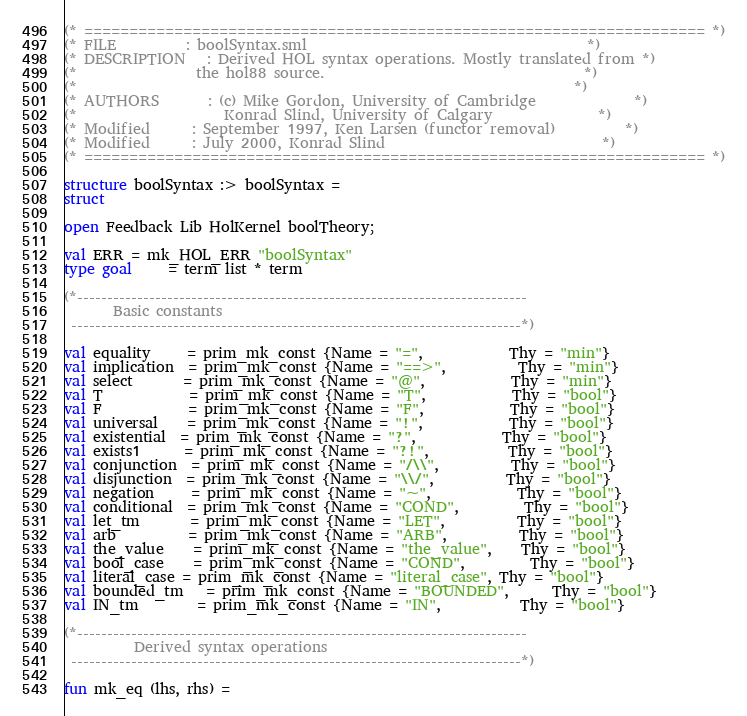Convert code to text. <code><loc_0><loc_0><loc_500><loc_500><_SML_>(* ===================================================================== *)
(* FILE          : boolSyntax.sml                                        *)
(* DESCRIPTION   : Derived HOL syntax operations. Mostly translated from *)
(*                 the hol88 source.                                     *)
(*                                                                       *)
(* AUTHORS       : (c) Mike Gordon, University of Cambridge              *)
(*                     Konrad Slind, University of Calgary               *)
(* Modified      : September 1997, Ken Larsen (functor removal)          *)
(* Modified      : July 2000, Konrad Slind                               *)
(* ===================================================================== *)

structure boolSyntax :> boolSyntax =
struct

open Feedback Lib HolKernel boolTheory;

val ERR = mk_HOL_ERR "boolSyntax"
type goal     = term list * term

(*---------------------------------------------------------------------------
       Basic constants
 ---------------------------------------------------------------------------*)

val equality     = prim_mk_const {Name = "=",            Thy = "min"}
val implication  = prim_mk_const {Name = "==>",          Thy = "min"}
val select       = prim_mk_const {Name = "@",            Thy = "min"}
val T            = prim_mk_const {Name = "T",            Thy = "bool"}
val F            = prim_mk_const {Name = "F",            Thy = "bool"}
val universal    = prim_mk_const {Name = "!",            Thy = "bool"}
val existential  = prim_mk_const {Name = "?",            Thy = "bool"}
val exists1      = prim_mk_const {Name = "?!",           Thy = "bool"}
val conjunction  = prim_mk_const {Name = "/\\",          Thy = "bool"}
val disjunction  = prim_mk_const {Name = "\\/",          Thy = "bool"}
val negation     = prim_mk_const {Name = "~",            Thy = "bool"}
val conditional  = prim_mk_const {Name = "COND",         Thy = "bool"}
val let_tm       = prim_mk_const {Name = "LET",          Thy = "bool"}
val arb          = prim_mk_const {Name = "ARB",          Thy = "bool"}
val the_value    = prim_mk_const {Name = "the_value",    Thy = "bool"}
val bool_case    = prim_mk_const {Name = "COND",         Thy = "bool"}
val literal_case = prim_mk_const {Name = "literal_case", Thy = "bool"}
val bounded_tm   = prim_mk_const {Name = "BOUNDED",      Thy = "bool"}
val IN_tm        = prim_mk_const {Name = "IN",           Thy = "bool"}

(*---------------------------------------------------------------------------
          Derived syntax operations
 ---------------------------------------------------------------------------*)

fun mk_eq (lhs, rhs) =</code> 